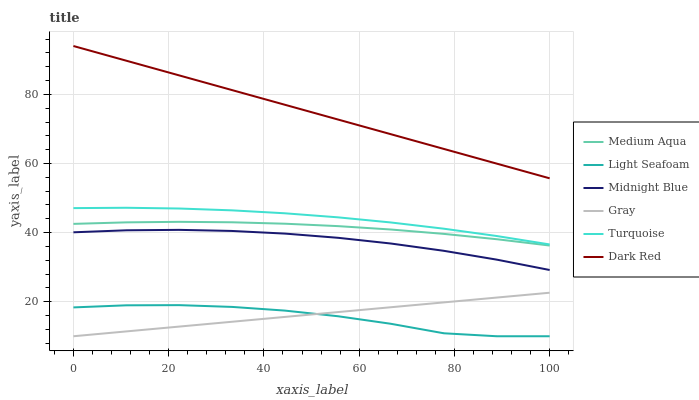Does Light Seafoam have the minimum area under the curve?
Answer yes or no. Yes. Does Dark Red have the maximum area under the curve?
Answer yes or no. Yes. Does Turquoise have the minimum area under the curve?
Answer yes or no. No. Does Turquoise have the maximum area under the curve?
Answer yes or no. No. Is Gray the smoothest?
Answer yes or no. Yes. Is Light Seafoam the roughest?
Answer yes or no. Yes. Is Turquoise the smoothest?
Answer yes or no. No. Is Turquoise the roughest?
Answer yes or no. No. Does Turquoise have the lowest value?
Answer yes or no. No. Does Dark Red have the highest value?
Answer yes or no. Yes. Does Turquoise have the highest value?
Answer yes or no. No. Is Gray less than Turquoise?
Answer yes or no. Yes. Is Dark Red greater than Turquoise?
Answer yes or no. Yes. Does Gray intersect Light Seafoam?
Answer yes or no. Yes. Is Gray less than Light Seafoam?
Answer yes or no. No. Is Gray greater than Light Seafoam?
Answer yes or no. No. Does Gray intersect Turquoise?
Answer yes or no. No. 